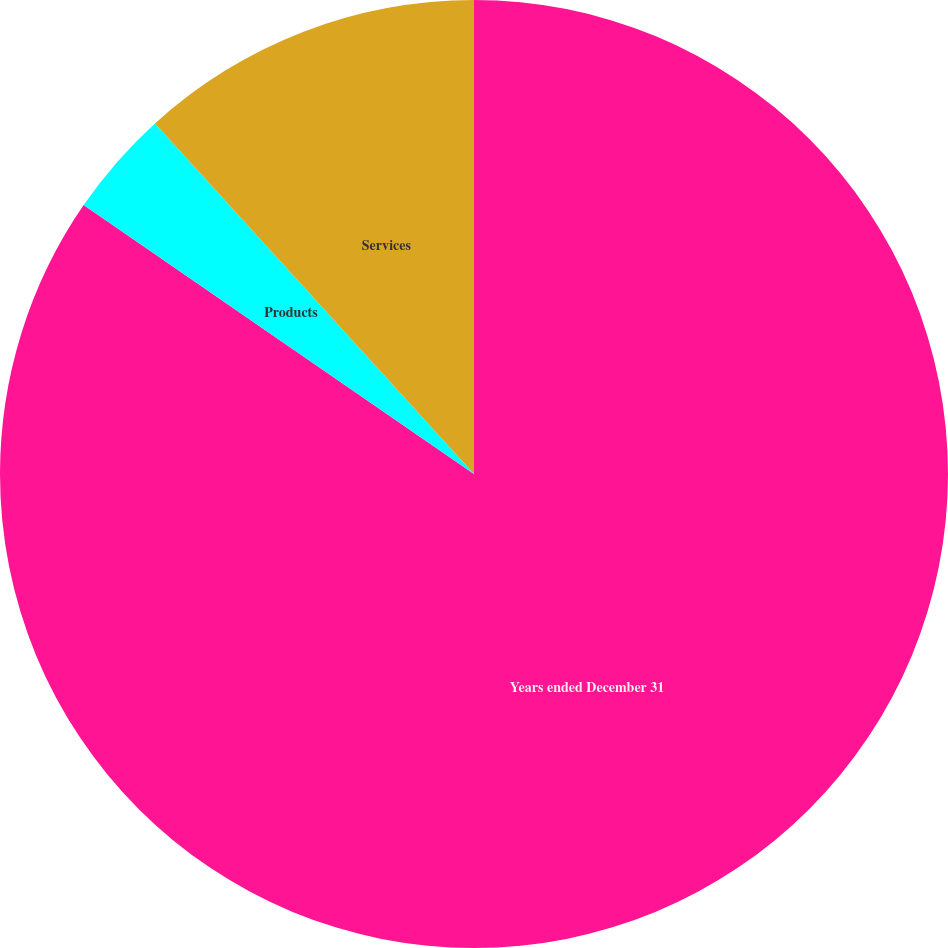<chart> <loc_0><loc_0><loc_500><loc_500><pie_chart><fcel>Years ended December 31<fcel>Products<fcel>Services<nl><fcel>84.6%<fcel>3.65%<fcel>11.75%<nl></chart> 